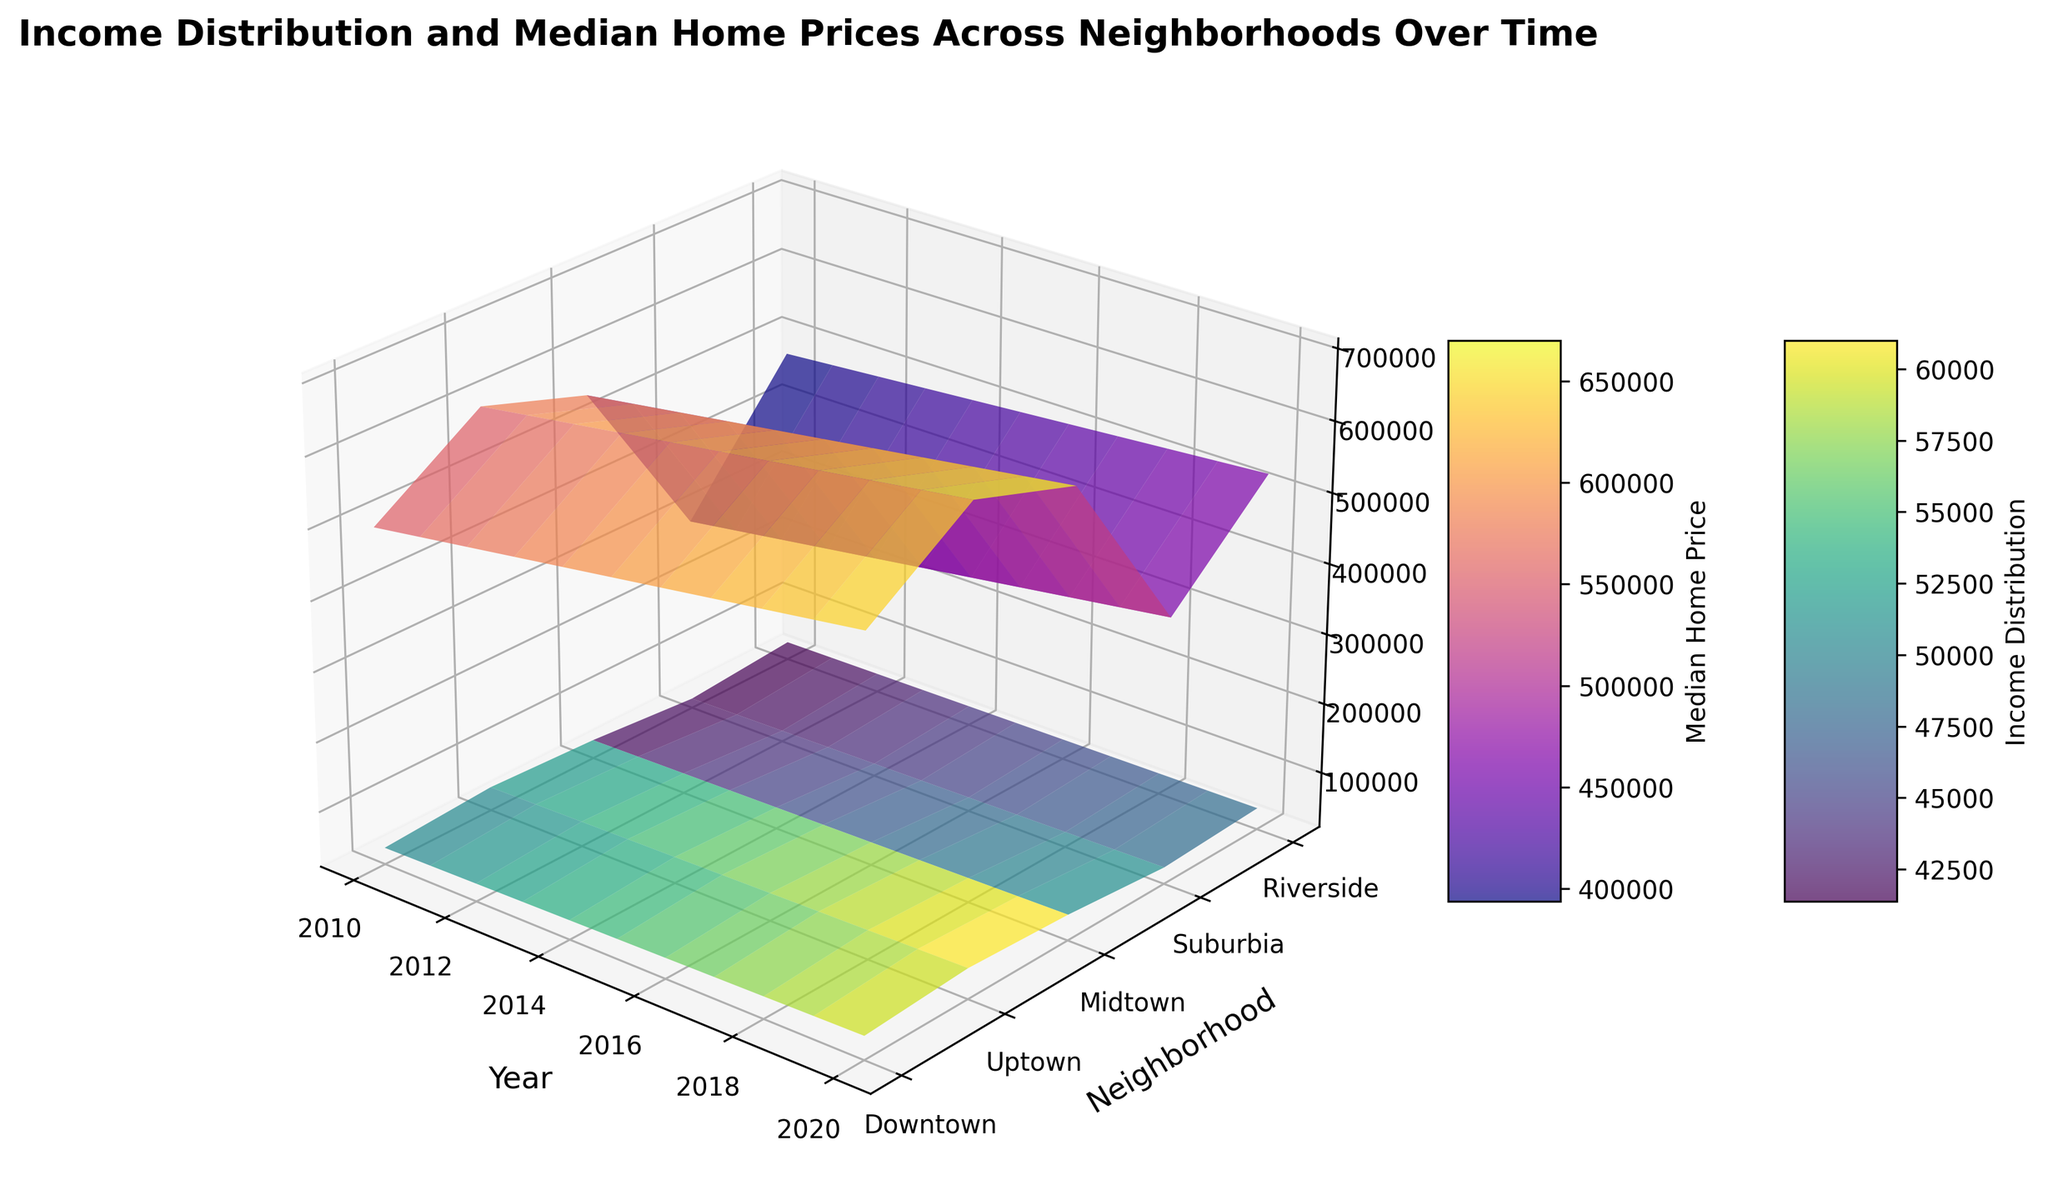What is the trend in median home prices in the Downtown neighborhood from 2010 to 2020? Look at the surface representing the Downtown neighborhood for each year and see how the median home price values change over time. The surface gradually increases each year.
Answer: Increasing How does the income distribution in Suburbia compare to Riverside in 2015? Refer to the surfaces indicating the income distribution for Suburbia and Riverside in 2015; by visual height comparison, Suburbia has a lower value than Riverside.
Answer: Lower Which neighborhood shows the highest median home price in 2018? Check the height of the surface corresponding to each neighborhood in 2018. The Uptown neighborhood shows the highest value in 2018.
Answer: Uptown What is the difference in the median home price between Uptown and Midtown in 2020? Compare the height of the surfaces representing Uptown and Midtown for 2020. Subtract Midtown’s value from Uptown’s value.
Answer: 50000 Considering the entire span of years, which neighborhood has the least variation in income distribution over time? Observe the surfaces representing income distribution for each neighborhood across the years. The neighborhood with the most consistent surface height is Riverside.
Answer: Riverside What is the average median home price in Riverside across all years? Sum all median home prices for Riverside (from 2010 to 2020) and divide by the number of years. The values are: 480000, 485000, 490000, 495000, 500000, 505000, 510000, 515000, 520000, 525000, 530000. The sum is 5450000, dividing by 11 gives the average of 495000.
Answer: 495000 Which year shows the highest overall income distribution across all neighborhoods? Identify the year where the surface levels for income distribution are the highest across the neighborhoods. The year 2020 has the highest overall surface levels.
Answer: 2020 Do the income distribution and median home price trends in Suburbia show similar patterns? Evaluate the surfaces for income distribution and median home price in Suburbia over time. Both surfaces show a gradual increase over the years, indicating similar trends.
Answer: Yes 